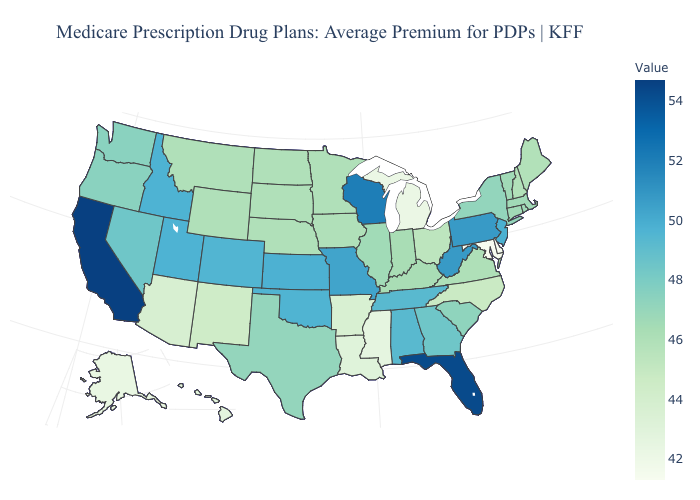Does Michigan have the lowest value in the MidWest?
Short answer required. Yes. Among the states that border Wisconsin , does Illinois have the highest value?
Give a very brief answer. Yes. Among the states that border Rhode Island , which have the lowest value?
Short answer required. Connecticut, Massachusetts. Does Arkansas have the lowest value in the South?
Write a very short answer. No. Does Wisconsin have the highest value in the MidWest?
Short answer required. Yes. 